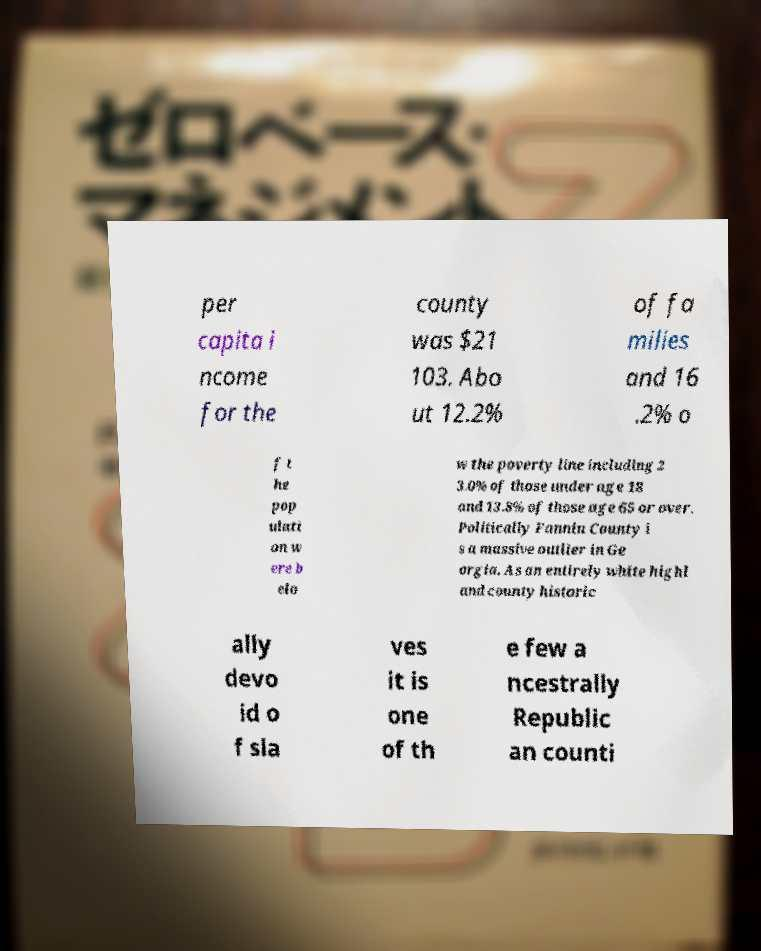There's text embedded in this image that I need extracted. Can you transcribe it verbatim? per capita i ncome for the county was $21 103. Abo ut 12.2% of fa milies and 16 .2% o f t he pop ulati on w ere b elo w the poverty line including 2 3.0% of those under age 18 and 13.8% of those age 65 or over. Politically Fannin County i s a massive outlier in Ge orgia. As an entirely white highl and county historic ally devo id o f sla ves it is one of th e few a ncestrally Republic an counti 